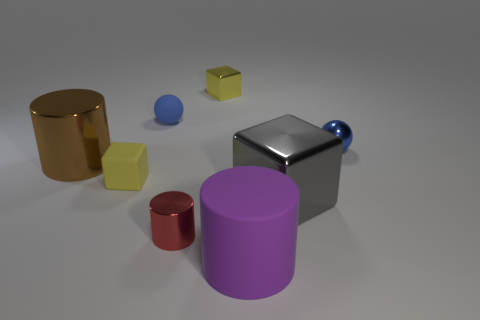Subtract all large cylinders. How many cylinders are left? 1 Add 1 tiny objects. How many objects exist? 9 Subtract all blue balls. How many yellow blocks are left? 2 Subtract all yellow blocks. How many blocks are left? 1 Subtract all balls. How many objects are left? 6 Subtract 1 cylinders. How many cylinders are left? 2 Subtract all gray cubes. Subtract all blue cylinders. How many cubes are left? 2 Subtract all blue things. Subtract all cyan rubber cylinders. How many objects are left? 6 Add 5 big rubber cylinders. How many big rubber cylinders are left? 6 Add 5 yellow matte blocks. How many yellow matte blocks exist? 6 